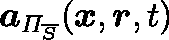Convert formula to latex. <formula><loc_0><loc_0><loc_500><loc_500>a _ { \Pi _ { \overline { S } } } ( x , r , t )</formula> 